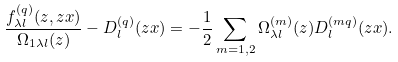Convert formula to latex. <formula><loc_0><loc_0><loc_500><loc_500>\frac { f _ { \lambda l } ^ { ( q ) } ( z , z x ) } { \Omega _ { 1 \lambda l } ( z ) } - D _ { l } ^ { ( q ) } ( z x ) = - \frac { 1 } { 2 } \sum _ { m = 1 , 2 } \Omega ^ { ( m ) } _ { \lambda l } ( z ) D _ { l } ^ { ( m q ) } ( z x ) .</formula> 